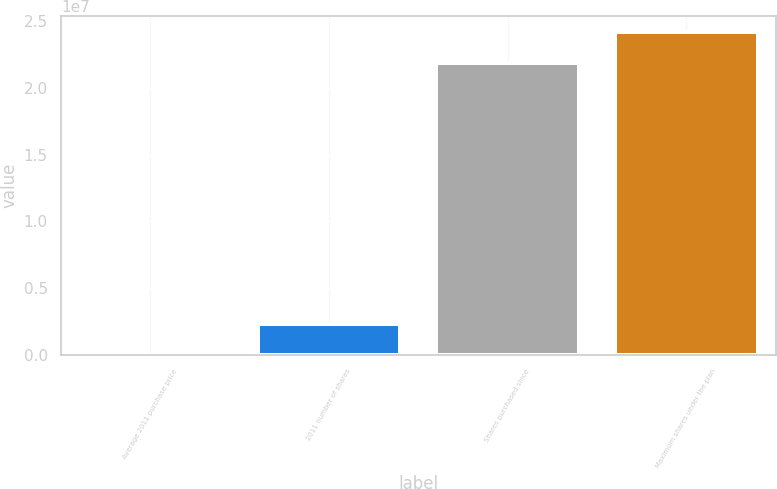Convert chart to OTSL. <chart><loc_0><loc_0><loc_500><loc_500><bar_chart><fcel>Average 2011 purchase price<fcel>2011 number of shares<fcel>Shares purchased since<fcel>Maximum shares under the plan<nl><fcel>19.51<fcel>2.30002e+06<fcel>2.18948e+07<fcel>2.41948e+07<nl></chart> 